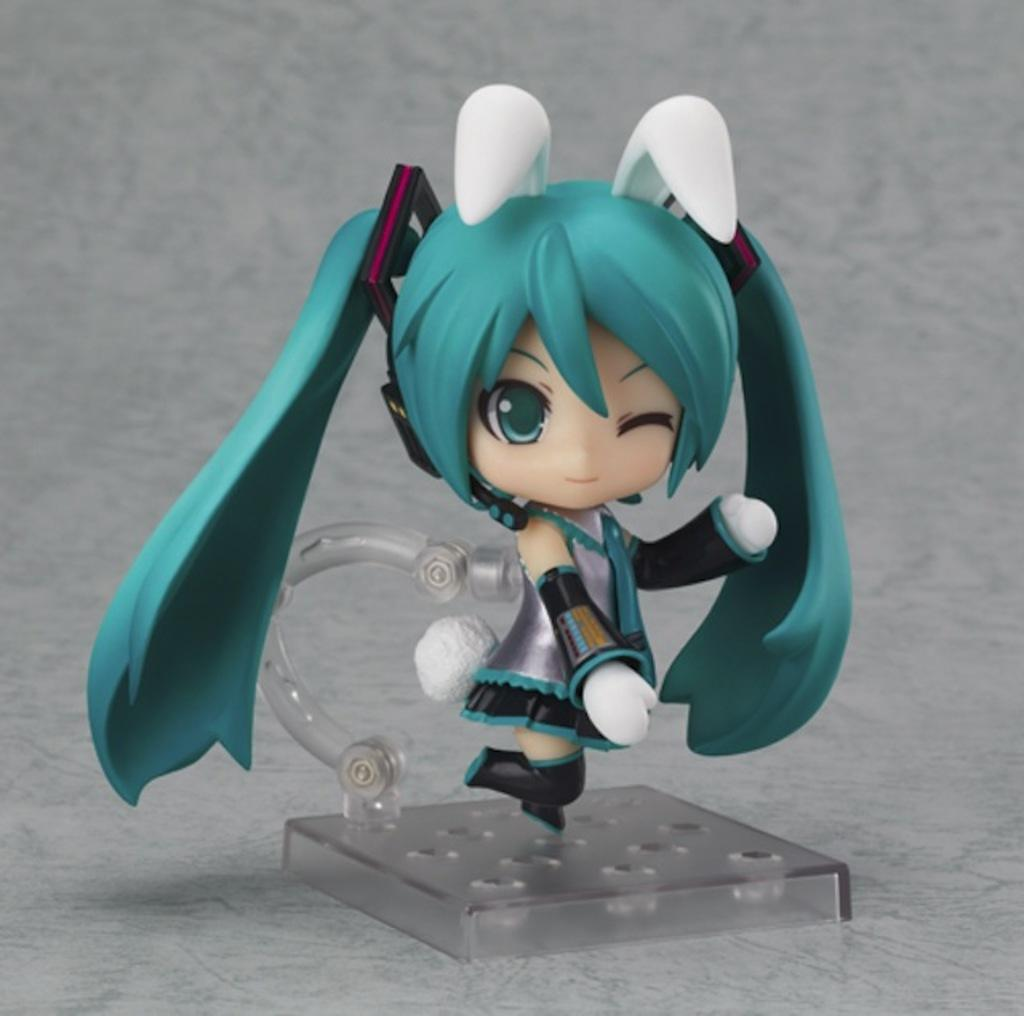What is placed on a surface in the image? There is a toy placed on a surface. Can you describe the toy in the image? The provided facts do not give any details about the toy's appearance or type. What might the toy be used for? The toy could be used for play or decoration, but the specific purpose is not mentioned in the facts. How many bees are sitting on the toy in the image? There is no mention of bees in the provided facts, so it cannot be determined if any bees are present in the image. 